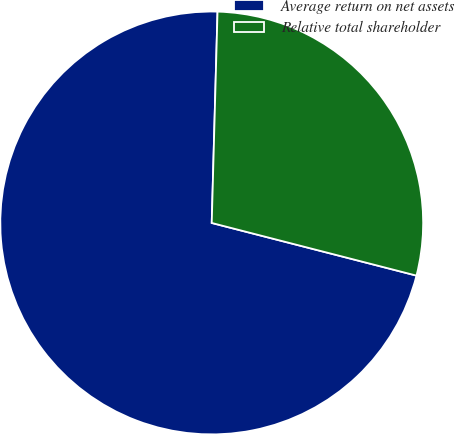Convert chart to OTSL. <chart><loc_0><loc_0><loc_500><loc_500><pie_chart><fcel>Average return on net assets<fcel>Relative total shareholder<nl><fcel>71.43%<fcel>28.57%<nl></chart> 